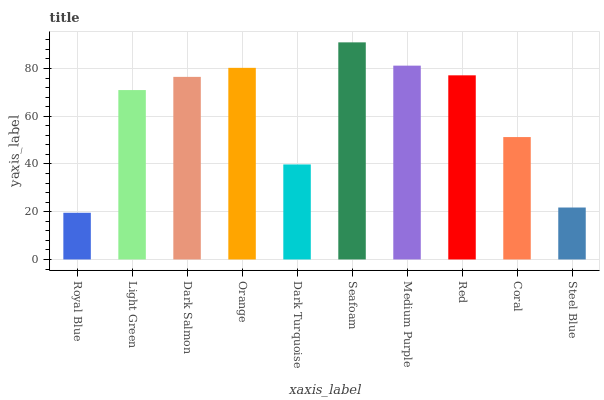Is Light Green the minimum?
Answer yes or no. No. Is Light Green the maximum?
Answer yes or no. No. Is Light Green greater than Royal Blue?
Answer yes or no. Yes. Is Royal Blue less than Light Green?
Answer yes or no. Yes. Is Royal Blue greater than Light Green?
Answer yes or no. No. Is Light Green less than Royal Blue?
Answer yes or no. No. Is Dark Salmon the high median?
Answer yes or no. Yes. Is Light Green the low median?
Answer yes or no. Yes. Is Light Green the high median?
Answer yes or no. No. Is Royal Blue the low median?
Answer yes or no. No. 